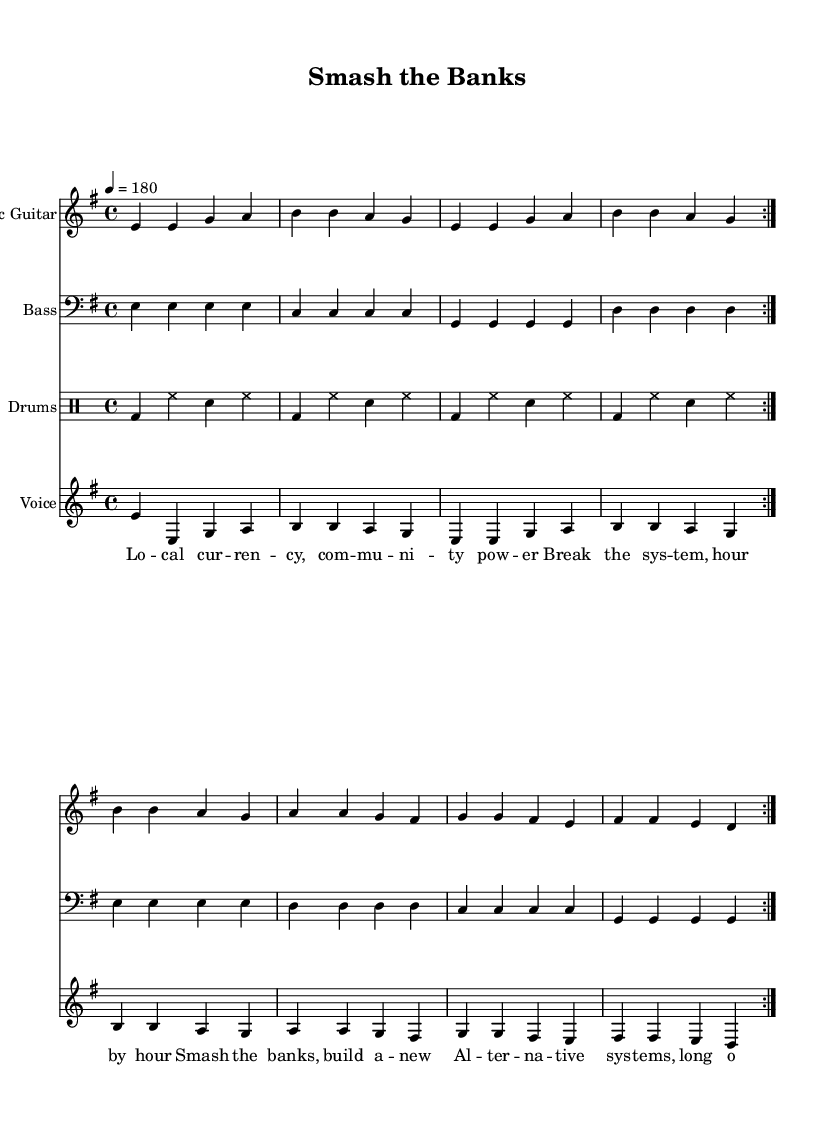What is the key signature of this music? The key signature indicated at the beginning of the sheet music shows one sharp (F#), which corresponds to E minor.
Answer: E minor What is the time signature of this music? The time signature displayed at the beginning indicates that there are 4 beats per measure with a quarter note getting one beat. This is a common time signature referred to as 4/4.
Answer: 4/4 What is the tempo marking for this piece? The tempo marking provided near the top indicates 180 beats per minute, which suggests a fast-paced rhythm suitable for punk music.
Answer: 180 How many measures are repeated in the main musical section? The repeat sign in the score indicates that the section is repeated twice, which is common in punk music to emphasize the energy and thematic content.
Answer: 2 What is the primary theme of the lyrics? The lyrics focus on community power and the need to break away from traditional economic systems, which reflects the punk ethos of rebellion and change.
Answer: Community power What instruments are featured in this song? The sheet music includes sections for electric guitar, bass guitar, drums, and vocals, characteristic of a punk band arrangement.
Answer: Electric guitar, bass, drums, vocals What forms the structure of the song? The song follows a structure typical of punk music with clearly defined verses and a chorus, allowing for energetic participation from listeners.
Answer: Verse and chorus 